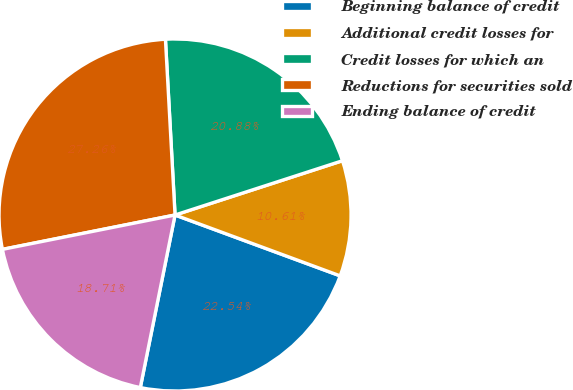Convert chart. <chart><loc_0><loc_0><loc_500><loc_500><pie_chart><fcel>Beginning balance of credit<fcel>Additional credit losses for<fcel>Credit losses for which an<fcel>Reductions for securities sold<fcel>Ending balance of credit<nl><fcel>22.54%<fcel>10.61%<fcel>20.88%<fcel>27.26%<fcel>18.71%<nl></chart> 